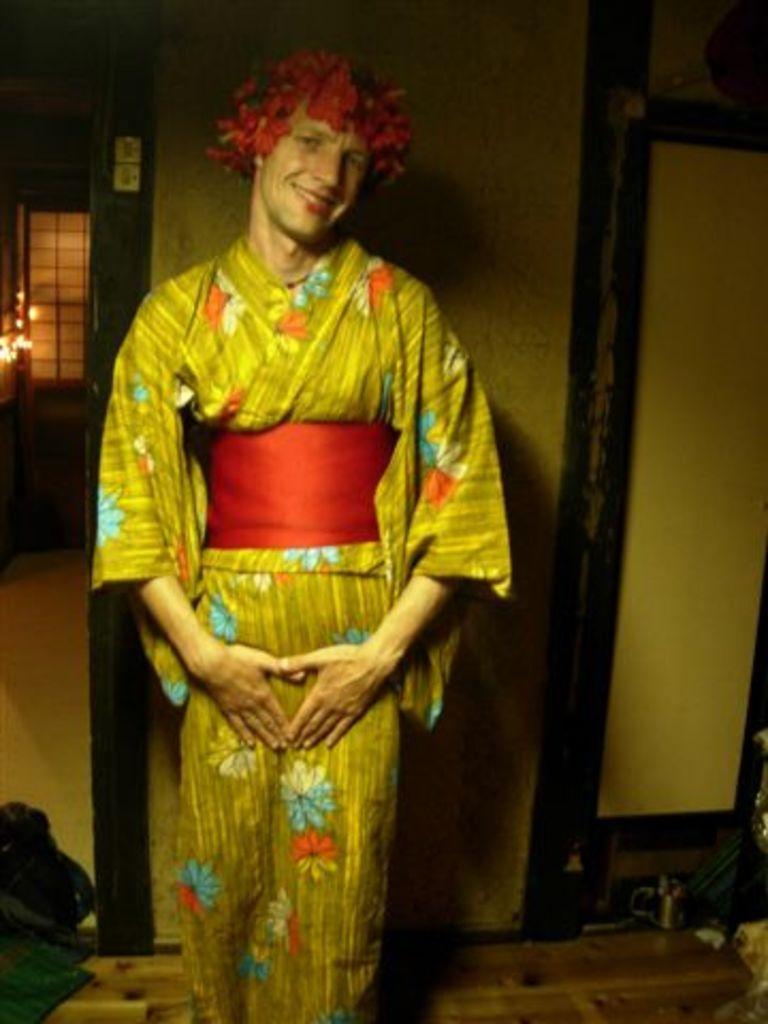Could you give a brief overview of what you see in this image? In the center of the image, we can see a person standing and wearing costume. In the background, there is a wall and we can see a window and some lights. At the bottom, there are some objects on the floor. 